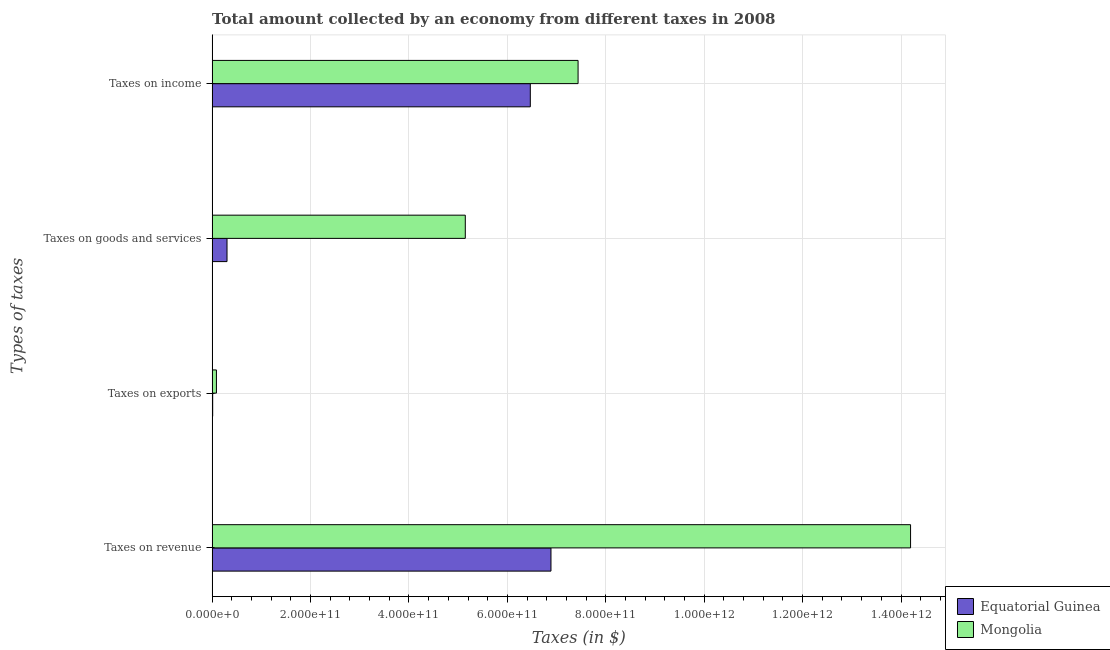How many different coloured bars are there?
Provide a short and direct response. 2. How many groups of bars are there?
Give a very brief answer. 4. Are the number of bars per tick equal to the number of legend labels?
Give a very brief answer. Yes. Are the number of bars on each tick of the Y-axis equal?
Your answer should be very brief. Yes. How many bars are there on the 3rd tick from the top?
Your answer should be compact. 2. What is the label of the 3rd group of bars from the top?
Provide a short and direct response. Taxes on exports. What is the amount collected as tax on income in Equatorial Guinea?
Keep it short and to the point. 6.47e+11. Across all countries, what is the maximum amount collected as tax on exports?
Keep it short and to the point. 8.78e+09. Across all countries, what is the minimum amount collected as tax on goods?
Your response must be concise. 3.03e+1. In which country was the amount collected as tax on exports maximum?
Give a very brief answer. Mongolia. In which country was the amount collected as tax on goods minimum?
Provide a short and direct response. Equatorial Guinea. What is the total amount collected as tax on goods in the graph?
Provide a short and direct response. 5.45e+11. What is the difference between the amount collected as tax on revenue in Equatorial Guinea and that in Mongolia?
Your response must be concise. -7.31e+11. What is the difference between the amount collected as tax on goods in Equatorial Guinea and the amount collected as tax on exports in Mongolia?
Your answer should be very brief. 2.15e+1. What is the average amount collected as tax on revenue per country?
Provide a succinct answer. 1.05e+12. What is the difference between the amount collected as tax on exports and amount collected as tax on income in Equatorial Guinea?
Ensure brevity in your answer.  -6.46e+11. In how many countries, is the amount collected as tax on goods greater than 1280000000000 $?
Your answer should be compact. 0. What is the ratio of the amount collected as tax on revenue in Mongolia to that in Equatorial Guinea?
Give a very brief answer. 2.06. Is the difference between the amount collected as tax on exports in Mongolia and Equatorial Guinea greater than the difference between the amount collected as tax on income in Mongolia and Equatorial Guinea?
Give a very brief answer. No. What is the difference between the highest and the second highest amount collected as tax on goods?
Keep it short and to the point. 4.84e+11. What is the difference between the highest and the lowest amount collected as tax on revenue?
Your answer should be very brief. 7.31e+11. In how many countries, is the amount collected as tax on income greater than the average amount collected as tax on income taken over all countries?
Provide a short and direct response. 1. What does the 2nd bar from the top in Taxes on exports represents?
Your answer should be very brief. Equatorial Guinea. What does the 2nd bar from the bottom in Taxes on revenue represents?
Ensure brevity in your answer.  Mongolia. Is it the case that in every country, the sum of the amount collected as tax on revenue and amount collected as tax on exports is greater than the amount collected as tax on goods?
Offer a terse response. Yes. What is the difference between two consecutive major ticks on the X-axis?
Make the answer very short. 2.00e+11. Does the graph contain any zero values?
Provide a succinct answer. No. How many legend labels are there?
Ensure brevity in your answer.  2. What is the title of the graph?
Make the answer very short. Total amount collected by an economy from different taxes in 2008. What is the label or title of the X-axis?
Offer a very short reply. Taxes (in $). What is the label or title of the Y-axis?
Provide a short and direct response. Types of taxes. What is the Taxes (in $) of Equatorial Guinea in Taxes on revenue?
Ensure brevity in your answer.  6.89e+11. What is the Taxes (in $) of Mongolia in Taxes on revenue?
Give a very brief answer. 1.42e+12. What is the Taxes (in $) of Equatorial Guinea in Taxes on exports?
Your answer should be compact. 1.14e+09. What is the Taxes (in $) of Mongolia in Taxes on exports?
Offer a very short reply. 8.78e+09. What is the Taxes (in $) in Equatorial Guinea in Taxes on goods and services?
Ensure brevity in your answer.  3.03e+1. What is the Taxes (in $) of Mongolia in Taxes on goods and services?
Keep it short and to the point. 5.15e+11. What is the Taxes (in $) of Equatorial Guinea in Taxes on income?
Keep it short and to the point. 6.47e+11. What is the Taxes (in $) of Mongolia in Taxes on income?
Keep it short and to the point. 7.44e+11. Across all Types of taxes, what is the maximum Taxes (in $) in Equatorial Guinea?
Provide a short and direct response. 6.89e+11. Across all Types of taxes, what is the maximum Taxes (in $) in Mongolia?
Provide a short and direct response. 1.42e+12. Across all Types of taxes, what is the minimum Taxes (in $) in Equatorial Guinea?
Your response must be concise. 1.14e+09. Across all Types of taxes, what is the minimum Taxes (in $) of Mongolia?
Ensure brevity in your answer.  8.78e+09. What is the total Taxes (in $) in Equatorial Guinea in the graph?
Ensure brevity in your answer.  1.37e+12. What is the total Taxes (in $) in Mongolia in the graph?
Provide a short and direct response. 2.69e+12. What is the difference between the Taxes (in $) of Equatorial Guinea in Taxes on revenue and that in Taxes on exports?
Provide a short and direct response. 6.87e+11. What is the difference between the Taxes (in $) in Mongolia in Taxes on revenue and that in Taxes on exports?
Offer a very short reply. 1.41e+12. What is the difference between the Taxes (in $) of Equatorial Guinea in Taxes on revenue and that in Taxes on goods and services?
Your answer should be very brief. 6.58e+11. What is the difference between the Taxes (in $) of Mongolia in Taxes on revenue and that in Taxes on goods and services?
Ensure brevity in your answer.  9.05e+11. What is the difference between the Taxes (in $) of Equatorial Guinea in Taxes on revenue and that in Taxes on income?
Ensure brevity in your answer.  4.20e+1. What is the difference between the Taxes (in $) in Mongolia in Taxes on revenue and that in Taxes on income?
Your answer should be very brief. 6.76e+11. What is the difference between the Taxes (in $) of Equatorial Guinea in Taxes on exports and that in Taxes on goods and services?
Provide a short and direct response. -2.91e+1. What is the difference between the Taxes (in $) in Mongolia in Taxes on exports and that in Taxes on goods and services?
Offer a very short reply. -5.06e+11. What is the difference between the Taxes (in $) of Equatorial Guinea in Taxes on exports and that in Taxes on income?
Keep it short and to the point. -6.46e+11. What is the difference between the Taxes (in $) of Mongolia in Taxes on exports and that in Taxes on income?
Ensure brevity in your answer.  -7.35e+11. What is the difference between the Taxes (in $) in Equatorial Guinea in Taxes on goods and services and that in Taxes on income?
Provide a succinct answer. -6.16e+11. What is the difference between the Taxes (in $) of Mongolia in Taxes on goods and services and that in Taxes on income?
Keep it short and to the point. -2.29e+11. What is the difference between the Taxes (in $) of Equatorial Guinea in Taxes on revenue and the Taxes (in $) of Mongolia in Taxes on exports?
Your answer should be compact. 6.80e+11. What is the difference between the Taxes (in $) in Equatorial Guinea in Taxes on revenue and the Taxes (in $) in Mongolia in Taxes on goods and services?
Make the answer very short. 1.74e+11. What is the difference between the Taxes (in $) of Equatorial Guinea in Taxes on revenue and the Taxes (in $) of Mongolia in Taxes on income?
Make the answer very short. -5.51e+1. What is the difference between the Taxes (in $) in Equatorial Guinea in Taxes on exports and the Taxes (in $) in Mongolia in Taxes on goods and services?
Give a very brief answer. -5.13e+11. What is the difference between the Taxes (in $) in Equatorial Guinea in Taxes on exports and the Taxes (in $) in Mongolia in Taxes on income?
Keep it short and to the point. -7.43e+11. What is the difference between the Taxes (in $) of Equatorial Guinea in Taxes on goods and services and the Taxes (in $) of Mongolia in Taxes on income?
Keep it short and to the point. -7.13e+11. What is the average Taxes (in $) in Equatorial Guinea per Types of taxes?
Provide a succinct answer. 3.42e+11. What is the average Taxes (in $) of Mongolia per Types of taxes?
Offer a terse response. 6.72e+11. What is the difference between the Taxes (in $) of Equatorial Guinea and Taxes (in $) of Mongolia in Taxes on revenue?
Offer a very short reply. -7.31e+11. What is the difference between the Taxes (in $) of Equatorial Guinea and Taxes (in $) of Mongolia in Taxes on exports?
Provide a short and direct response. -7.64e+09. What is the difference between the Taxes (in $) of Equatorial Guinea and Taxes (in $) of Mongolia in Taxes on goods and services?
Provide a short and direct response. -4.84e+11. What is the difference between the Taxes (in $) in Equatorial Guinea and Taxes (in $) in Mongolia in Taxes on income?
Your answer should be very brief. -9.70e+1. What is the ratio of the Taxes (in $) in Equatorial Guinea in Taxes on revenue to that in Taxes on exports?
Give a very brief answer. 603.54. What is the ratio of the Taxes (in $) of Mongolia in Taxes on revenue to that in Taxes on exports?
Offer a terse response. 161.62. What is the ratio of the Taxes (in $) in Equatorial Guinea in Taxes on revenue to that in Taxes on goods and services?
Keep it short and to the point. 22.76. What is the ratio of the Taxes (in $) in Mongolia in Taxes on revenue to that in Taxes on goods and services?
Make the answer very short. 2.76. What is the ratio of the Taxes (in $) in Equatorial Guinea in Taxes on revenue to that in Taxes on income?
Offer a terse response. 1.06. What is the ratio of the Taxes (in $) of Mongolia in Taxes on revenue to that in Taxes on income?
Make the answer very short. 1.91. What is the ratio of the Taxes (in $) of Equatorial Guinea in Taxes on exports to that in Taxes on goods and services?
Ensure brevity in your answer.  0.04. What is the ratio of the Taxes (in $) of Mongolia in Taxes on exports to that in Taxes on goods and services?
Your answer should be compact. 0.02. What is the ratio of the Taxes (in $) in Equatorial Guinea in Taxes on exports to that in Taxes on income?
Ensure brevity in your answer.  0. What is the ratio of the Taxes (in $) in Mongolia in Taxes on exports to that in Taxes on income?
Make the answer very short. 0.01. What is the ratio of the Taxes (in $) of Equatorial Guinea in Taxes on goods and services to that in Taxes on income?
Ensure brevity in your answer.  0.05. What is the ratio of the Taxes (in $) in Mongolia in Taxes on goods and services to that in Taxes on income?
Provide a succinct answer. 0.69. What is the difference between the highest and the second highest Taxes (in $) in Equatorial Guinea?
Your response must be concise. 4.20e+1. What is the difference between the highest and the second highest Taxes (in $) of Mongolia?
Give a very brief answer. 6.76e+11. What is the difference between the highest and the lowest Taxes (in $) in Equatorial Guinea?
Your answer should be compact. 6.87e+11. What is the difference between the highest and the lowest Taxes (in $) in Mongolia?
Make the answer very short. 1.41e+12. 